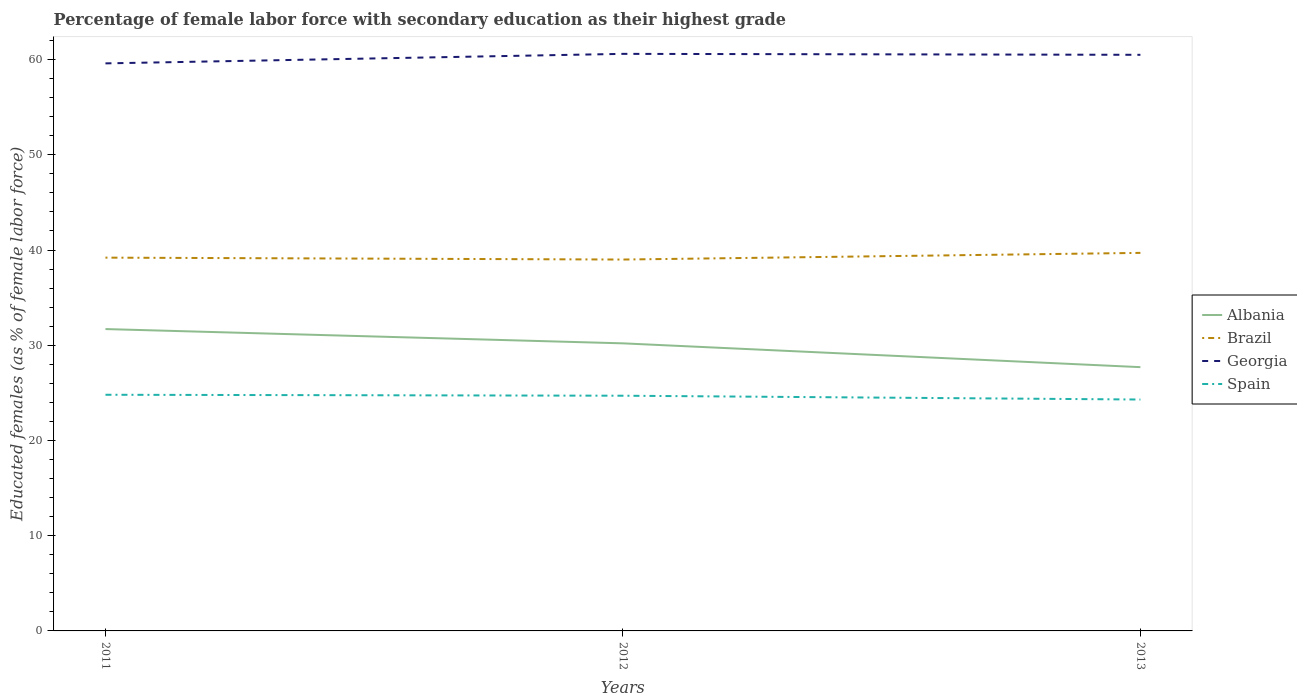How many different coloured lines are there?
Ensure brevity in your answer.  4. Does the line corresponding to Albania intersect with the line corresponding to Brazil?
Your response must be concise. No. Is the number of lines equal to the number of legend labels?
Offer a very short reply. Yes. Across all years, what is the maximum percentage of female labor force with secondary education in Georgia?
Provide a succinct answer. 59.6. What is the total percentage of female labor force with secondary education in Albania in the graph?
Offer a very short reply. 2.5. What is the difference between the highest and the lowest percentage of female labor force with secondary education in Albania?
Give a very brief answer. 2. How many years are there in the graph?
Your answer should be very brief. 3. Does the graph contain any zero values?
Make the answer very short. No. Where does the legend appear in the graph?
Provide a succinct answer. Center right. How many legend labels are there?
Offer a very short reply. 4. How are the legend labels stacked?
Keep it short and to the point. Vertical. What is the title of the graph?
Provide a succinct answer. Percentage of female labor force with secondary education as their highest grade. What is the label or title of the X-axis?
Keep it short and to the point. Years. What is the label or title of the Y-axis?
Offer a terse response. Educated females (as % of female labor force). What is the Educated females (as % of female labor force) of Albania in 2011?
Keep it short and to the point. 31.7. What is the Educated females (as % of female labor force) of Brazil in 2011?
Provide a short and direct response. 39.2. What is the Educated females (as % of female labor force) in Georgia in 2011?
Provide a short and direct response. 59.6. What is the Educated females (as % of female labor force) in Spain in 2011?
Keep it short and to the point. 24.8. What is the Educated females (as % of female labor force) in Albania in 2012?
Give a very brief answer. 30.2. What is the Educated females (as % of female labor force) in Brazil in 2012?
Keep it short and to the point. 39. What is the Educated females (as % of female labor force) of Georgia in 2012?
Provide a succinct answer. 60.6. What is the Educated females (as % of female labor force) of Spain in 2012?
Make the answer very short. 24.7. What is the Educated females (as % of female labor force) in Albania in 2013?
Keep it short and to the point. 27.7. What is the Educated females (as % of female labor force) of Brazil in 2013?
Provide a succinct answer. 39.7. What is the Educated females (as % of female labor force) in Georgia in 2013?
Offer a terse response. 60.5. What is the Educated females (as % of female labor force) of Spain in 2013?
Make the answer very short. 24.3. Across all years, what is the maximum Educated females (as % of female labor force) of Albania?
Your response must be concise. 31.7. Across all years, what is the maximum Educated females (as % of female labor force) of Brazil?
Provide a short and direct response. 39.7. Across all years, what is the maximum Educated females (as % of female labor force) in Georgia?
Make the answer very short. 60.6. Across all years, what is the maximum Educated females (as % of female labor force) of Spain?
Keep it short and to the point. 24.8. Across all years, what is the minimum Educated females (as % of female labor force) of Albania?
Offer a very short reply. 27.7. Across all years, what is the minimum Educated females (as % of female labor force) in Brazil?
Make the answer very short. 39. Across all years, what is the minimum Educated females (as % of female labor force) in Georgia?
Keep it short and to the point. 59.6. Across all years, what is the minimum Educated females (as % of female labor force) of Spain?
Give a very brief answer. 24.3. What is the total Educated females (as % of female labor force) of Albania in the graph?
Offer a very short reply. 89.6. What is the total Educated females (as % of female labor force) in Brazil in the graph?
Provide a succinct answer. 117.9. What is the total Educated females (as % of female labor force) in Georgia in the graph?
Keep it short and to the point. 180.7. What is the total Educated females (as % of female labor force) in Spain in the graph?
Offer a terse response. 73.8. What is the difference between the Educated females (as % of female labor force) of Brazil in 2011 and that in 2012?
Provide a succinct answer. 0.2. What is the difference between the Educated females (as % of female labor force) of Georgia in 2011 and that in 2013?
Keep it short and to the point. -0.9. What is the difference between the Educated females (as % of female labor force) of Albania in 2012 and that in 2013?
Make the answer very short. 2.5. What is the difference between the Educated females (as % of female labor force) in Brazil in 2012 and that in 2013?
Give a very brief answer. -0.7. What is the difference between the Educated females (as % of female labor force) of Georgia in 2012 and that in 2013?
Offer a very short reply. 0.1. What is the difference between the Educated females (as % of female labor force) in Spain in 2012 and that in 2013?
Provide a short and direct response. 0.4. What is the difference between the Educated females (as % of female labor force) in Albania in 2011 and the Educated females (as % of female labor force) in Brazil in 2012?
Keep it short and to the point. -7.3. What is the difference between the Educated females (as % of female labor force) of Albania in 2011 and the Educated females (as % of female labor force) of Georgia in 2012?
Your answer should be compact. -28.9. What is the difference between the Educated females (as % of female labor force) in Brazil in 2011 and the Educated females (as % of female labor force) in Georgia in 2012?
Offer a terse response. -21.4. What is the difference between the Educated females (as % of female labor force) of Brazil in 2011 and the Educated females (as % of female labor force) of Spain in 2012?
Give a very brief answer. 14.5. What is the difference between the Educated females (as % of female labor force) in Georgia in 2011 and the Educated females (as % of female labor force) in Spain in 2012?
Offer a terse response. 34.9. What is the difference between the Educated females (as % of female labor force) of Albania in 2011 and the Educated females (as % of female labor force) of Georgia in 2013?
Give a very brief answer. -28.8. What is the difference between the Educated females (as % of female labor force) of Albania in 2011 and the Educated females (as % of female labor force) of Spain in 2013?
Your answer should be compact. 7.4. What is the difference between the Educated females (as % of female labor force) of Brazil in 2011 and the Educated females (as % of female labor force) of Georgia in 2013?
Offer a very short reply. -21.3. What is the difference between the Educated females (as % of female labor force) of Georgia in 2011 and the Educated females (as % of female labor force) of Spain in 2013?
Offer a terse response. 35.3. What is the difference between the Educated females (as % of female labor force) in Albania in 2012 and the Educated females (as % of female labor force) in Brazil in 2013?
Your answer should be very brief. -9.5. What is the difference between the Educated females (as % of female labor force) in Albania in 2012 and the Educated females (as % of female labor force) in Georgia in 2013?
Offer a very short reply. -30.3. What is the difference between the Educated females (as % of female labor force) in Albania in 2012 and the Educated females (as % of female labor force) in Spain in 2013?
Your answer should be compact. 5.9. What is the difference between the Educated females (as % of female labor force) in Brazil in 2012 and the Educated females (as % of female labor force) in Georgia in 2013?
Make the answer very short. -21.5. What is the difference between the Educated females (as % of female labor force) in Brazil in 2012 and the Educated females (as % of female labor force) in Spain in 2013?
Provide a short and direct response. 14.7. What is the difference between the Educated females (as % of female labor force) in Georgia in 2012 and the Educated females (as % of female labor force) in Spain in 2013?
Provide a short and direct response. 36.3. What is the average Educated females (as % of female labor force) of Albania per year?
Provide a short and direct response. 29.87. What is the average Educated females (as % of female labor force) of Brazil per year?
Your answer should be very brief. 39.3. What is the average Educated females (as % of female labor force) of Georgia per year?
Your answer should be compact. 60.23. What is the average Educated females (as % of female labor force) of Spain per year?
Your response must be concise. 24.6. In the year 2011, what is the difference between the Educated females (as % of female labor force) in Albania and Educated females (as % of female labor force) in Georgia?
Keep it short and to the point. -27.9. In the year 2011, what is the difference between the Educated females (as % of female labor force) of Albania and Educated females (as % of female labor force) of Spain?
Offer a very short reply. 6.9. In the year 2011, what is the difference between the Educated females (as % of female labor force) in Brazil and Educated females (as % of female labor force) in Georgia?
Ensure brevity in your answer.  -20.4. In the year 2011, what is the difference between the Educated females (as % of female labor force) in Brazil and Educated females (as % of female labor force) in Spain?
Ensure brevity in your answer.  14.4. In the year 2011, what is the difference between the Educated females (as % of female labor force) in Georgia and Educated females (as % of female labor force) in Spain?
Keep it short and to the point. 34.8. In the year 2012, what is the difference between the Educated females (as % of female labor force) of Albania and Educated females (as % of female labor force) of Georgia?
Give a very brief answer. -30.4. In the year 2012, what is the difference between the Educated females (as % of female labor force) in Brazil and Educated females (as % of female labor force) in Georgia?
Your answer should be very brief. -21.6. In the year 2012, what is the difference between the Educated females (as % of female labor force) of Georgia and Educated females (as % of female labor force) of Spain?
Offer a very short reply. 35.9. In the year 2013, what is the difference between the Educated females (as % of female labor force) of Albania and Educated females (as % of female labor force) of Brazil?
Ensure brevity in your answer.  -12. In the year 2013, what is the difference between the Educated females (as % of female labor force) in Albania and Educated females (as % of female labor force) in Georgia?
Ensure brevity in your answer.  -32.8. In the year 2013, what is the difference between the Educated females (as % of female labor force) in Brazil and Educated females (as % of female labor force) in Georgia?
Your answer should be very brief. -20.8. In the year 2013, what is the difference between the Educated females (as % of female labor force) of Georgia and Educated females (as % of female labor force) of Spain?
Your answer should be compact. 36.2. What is the ratio of the Educated females (as % of female labor force) in Albania in 2011 to that in 2012?
Make the answer very short. 1.05. What is the ratio of the Educated females (as % of female labor force) in Brazil in 2011 to that in 2012?
Give a very brief answer. 1.01. What is the ratio of the Educated females (as % of female labor force) of Georgia in 2011 to that in 2012?
Ensure brevity in your answer.  0.98. What is the ratio of the Educated females (as % of female labor force) of Albania in 2011 to that in 2013?
Give a very brief answer. 1.14. What is the ratio of the Educated females (as % of female labor force) in Brazil in 2011 to that in 2013?
Your response must be concise. 0.99. What is the ratio of the Educated females (as % of female labor force) in Georgia in 2011 to that in 2013?
Ensure brevity in your answer.  0.99. What is the ratio of the Educated females (as % of female labor force) of Spain in 2011 to that in 2013?
Provide a short and direct response. 1.02. What is the ratio of the Educated females (as % of female labor force) in Albania in 2012 to that in 2013?
Your answer should be very brief. 1.09. What is the ratio of the Educated females (as % of female labor force) in Brazil in 2012 to that in 2013?
Provide a succinct answer. 0.98. What is the ratio of the Educated females (as % of female labor force) in Georgia in 2012 to that in 2013?
Keep it short and to the point. 1. What is the ratio of the Educated females (as % of female labor force) in Spain in 2012 to that in 2013?
Provide a succinct answer. 1.02. What is the difference between the highest and the second highest Educated females (as % of female labor force) of Albania?
Ensure brevity in your answer.  1.5. What is the difference between the highest and the second highest Educated females (as % of female labor force) of Georgia?
Provide a succinct answer. 0.1. What is the difference between the highest and the lowest Educated females (as % of female labor force) in Georgia?
Offer a very short reply. 1. What is the difference between the highest and the lowest Educated females (as % of female labor force) of Spain?
Provide a short and direct response. 0.5. 